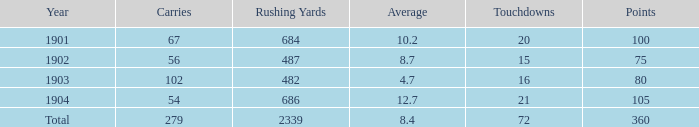What is the total of carries linked with 80 points and less than 16 touchdowns? None. 